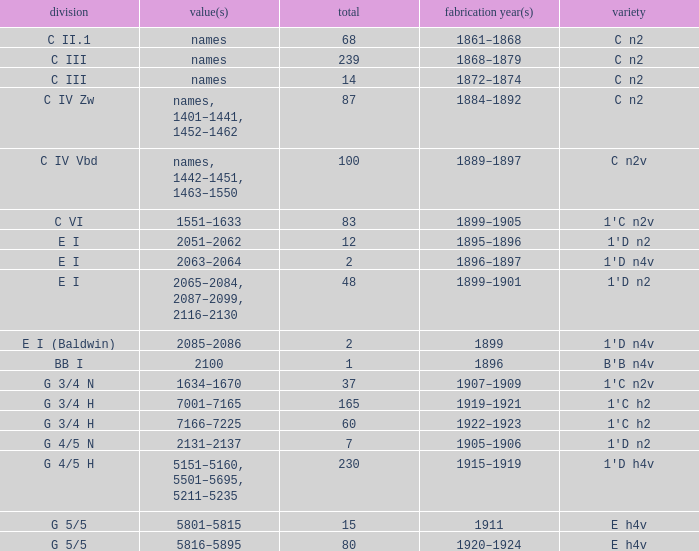Which Class has a Year(s) of Manufacture of 1899? E I (Baldwin). 